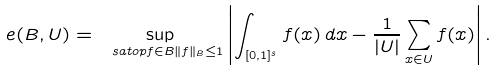Convert formula to latex. <formula><loc_0><loc_0><loc_500><loc_500>e ( B , U ) = \sup _ { \ s a t o p { f \in B } { \| f \| _ { B } \leq 1 } } \left | \int _ { [ 0 , 1 ] ^ { s } } f ( x ) \, d x - \frac { 1 } { | U | } \sum _ { x \in U } f ( x ) \right | .</formula> 